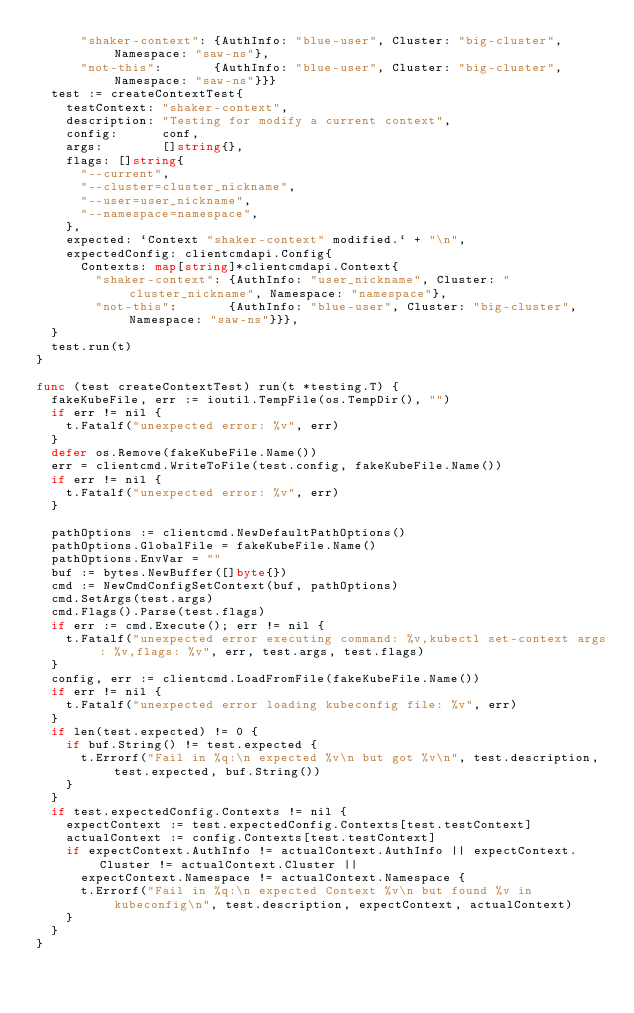<code> <loc_0><loc_0><loc_500><loc_500><_Go_>			"shaker-context": {AuthInfo: "blue-user", Cluster: "big-cluster", Namespace: "saw-ns"},
			"not-this":       {AuthInfo: "blue-user", Cluster: "big-cluster", Namespace: "saw-ns"}}}
	test := createContextTest{
		testContext: "shaker-context",
		description: "Testing for modify a current context",
		config:      conf,
		args:        []string{},
		flags: []string{
			"--current",
			"--cluster=cluster_nickname",
			"--user=user_nickname",
			"--namespace=namespace",
		},
		expected: `Context "shaker-context" modified.` + "\n",
		expectedConfig: clientcmdapi.Config{
			Contexts: map[string]*clientcmdapi.Context{
				"shaker-context": {AuthInfo: "user_nickname", Cluster: "cluster_nickname", Namespace: "namespace"},
				"not-this":       {AuthInfo: "blue-user", Cluster: "big-cluster", Namespace: "saw-ns"}}},
	}
	test.run(t)
}

func (test createContextTest) run(t *testing.T) {
	fakeKubeFile, err := ioutil.TempFile(os.TempDir(), "")
	if err != nil {
		t.Fatalf("unexpected error: %v", err)
	}
	defer os.Remove(fakeKubeFile.Name())
	err = clientcmd.WriteToFile(test.config, fakeKubeFile.Name())
	if err != nil {
		t.Fatalf("unexpected error: %v", err)
	}

	pathOptions := clientcmd.NewDefaultPathOptions()
	pathOptions.GlobalFile = fakeKubeFile.Name()
	pathOptions.EnvVar = ""
	buf := bytes.NewBuffer([]byte{})
	cmd := NewCmdConfigSetContext(buf, pathOptions)
	cmd.SetArgs(test.args)
	cmd.Flags().Parse(test.flags)
	if err := cmd.Execute(); err != nil {
		t.Fatalf("unexpected error executing command: %v,kubectl set-context args: %v,flags: %v", err, test.args, test.flags)
	}
	config, err := clientcmd.LoadFromFile(fakeKubeFile.Name())
	if err != nil {
		t.Fatalf("unexpected error loading kubeconfig file: %v", err)
	}
	if len(test.expected) != 0 {
		if buf.String() != test.expected {
			t.Errorf("Fail in %q:\n expected %v\n but got %v\n", test.description, test.expected, buf.String())
		}
	}
	if test.expectedConfig.Contexts != nil {
		expectContext := test.expectedConfig.Contexts[test.testContext]
		actualContext := config.Contexts[test.testContext]
		if expectContext.AuthInfo != actualContext.AuthInfo || expectContext.Cluster != actualContext.Cluster ||
			expectContext.Namespace != actualContext.Namespace {
			t.Errorf("Fail in %q:\n expected Context %v\n but found %v in kubeconfig\n", test.description, expectContext, actualContext)
		}
	}
}
</code> 